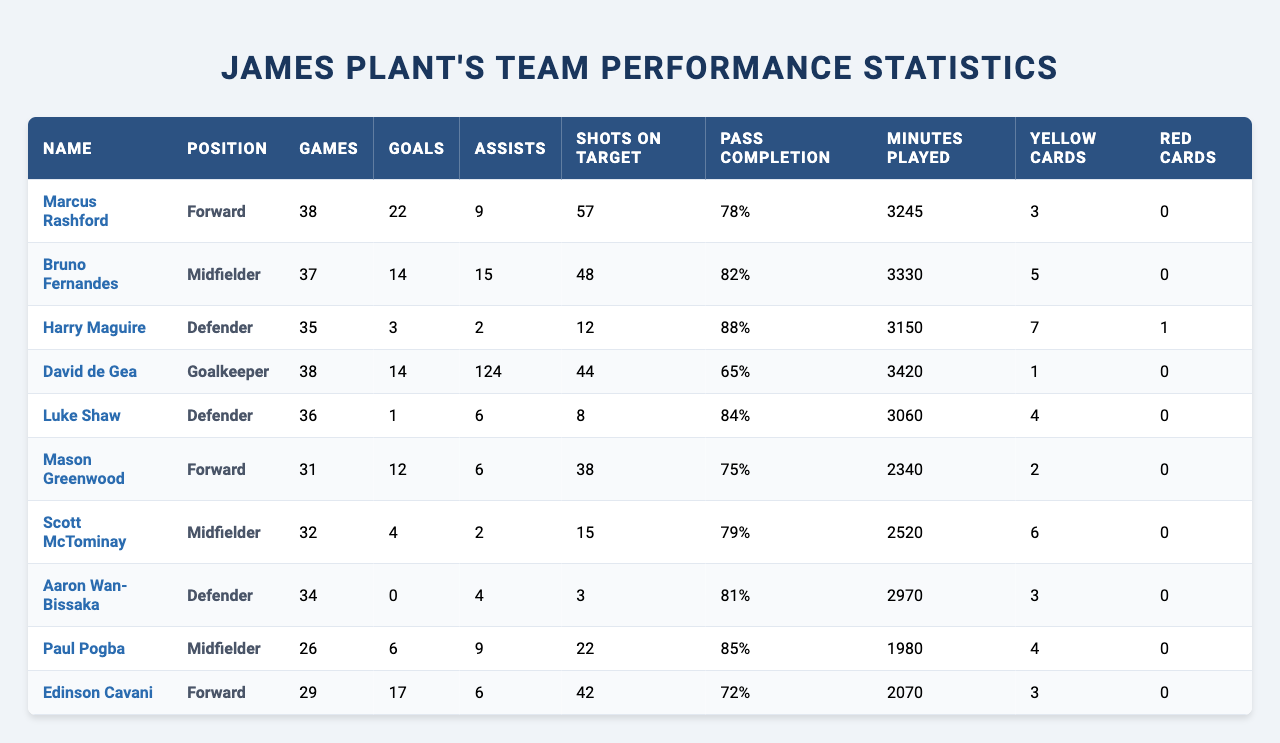What is the total number of goals scored by the players? To find the total goals, add all the goals scored by each player: 22 (Rashford) + 14 (Fernandes) + 3 (Maguire) + 0 (de Gea) + 1 (Shaw) + 12 (Greenwood) + 4 (McTominay) + 6 (Pogba) + 17 (Cavani) = 79
Answer: 79 Which player has the highest pass completion rate? By reviewing the pass completion rates, Harry Maguire has the highest at 88%, followed by Bruno Fernandes at 82%, and then Aaron Wan-Bissaka at 81%. No other player exceeds 88%.
Answer: Harry Maguire Did any player receive a red card? Checking the table, Harry Maguire has one red card, while all other players have received none.
Answer: Yes How many assists did Marcus Rashford provide? The table reveals that Marcus Rashford assisted 9 goals during the season.
Answer: 9 What is the average number of goals scored by the forwards? The forwards are Rashford (22), Greenwood (12), and Cavani (17). Adding these gives 51 goals, and with 3 forwards, the average is 51/3 = 17.
Answer: 17 Which midfielder has the most assists? Bruno Fernandes has the highest assists, at 15, compared to Scott McTominay (2), Pogba (9), and thus ranks highest among midfielders.
Answer: Bruno Fernandes How many yellow cards did Luke Shaw receive? The table indicates that Luke Shaw received 4 yellow cards throughout the season.
Answer: 4 Which player spent the most minutes on the field? David de Gea played 3420 minutes, the most among all listed players, with Fernandes and Rashford close behind.
Answer: David de Gea What is the total number of clean sheets recorded by David de Gea? According to the table, David de Gea achieved 14 clean sheets during the season.
Answer: 14 Did any defender score more than one goal? The only defenders listed are Maguire, Shaw, and Wan-Bissaka, with only Maguire scoring 3 goals and Shaw scoring 1. Thus, only one defender scored more than one goal.
Answer: Yes 